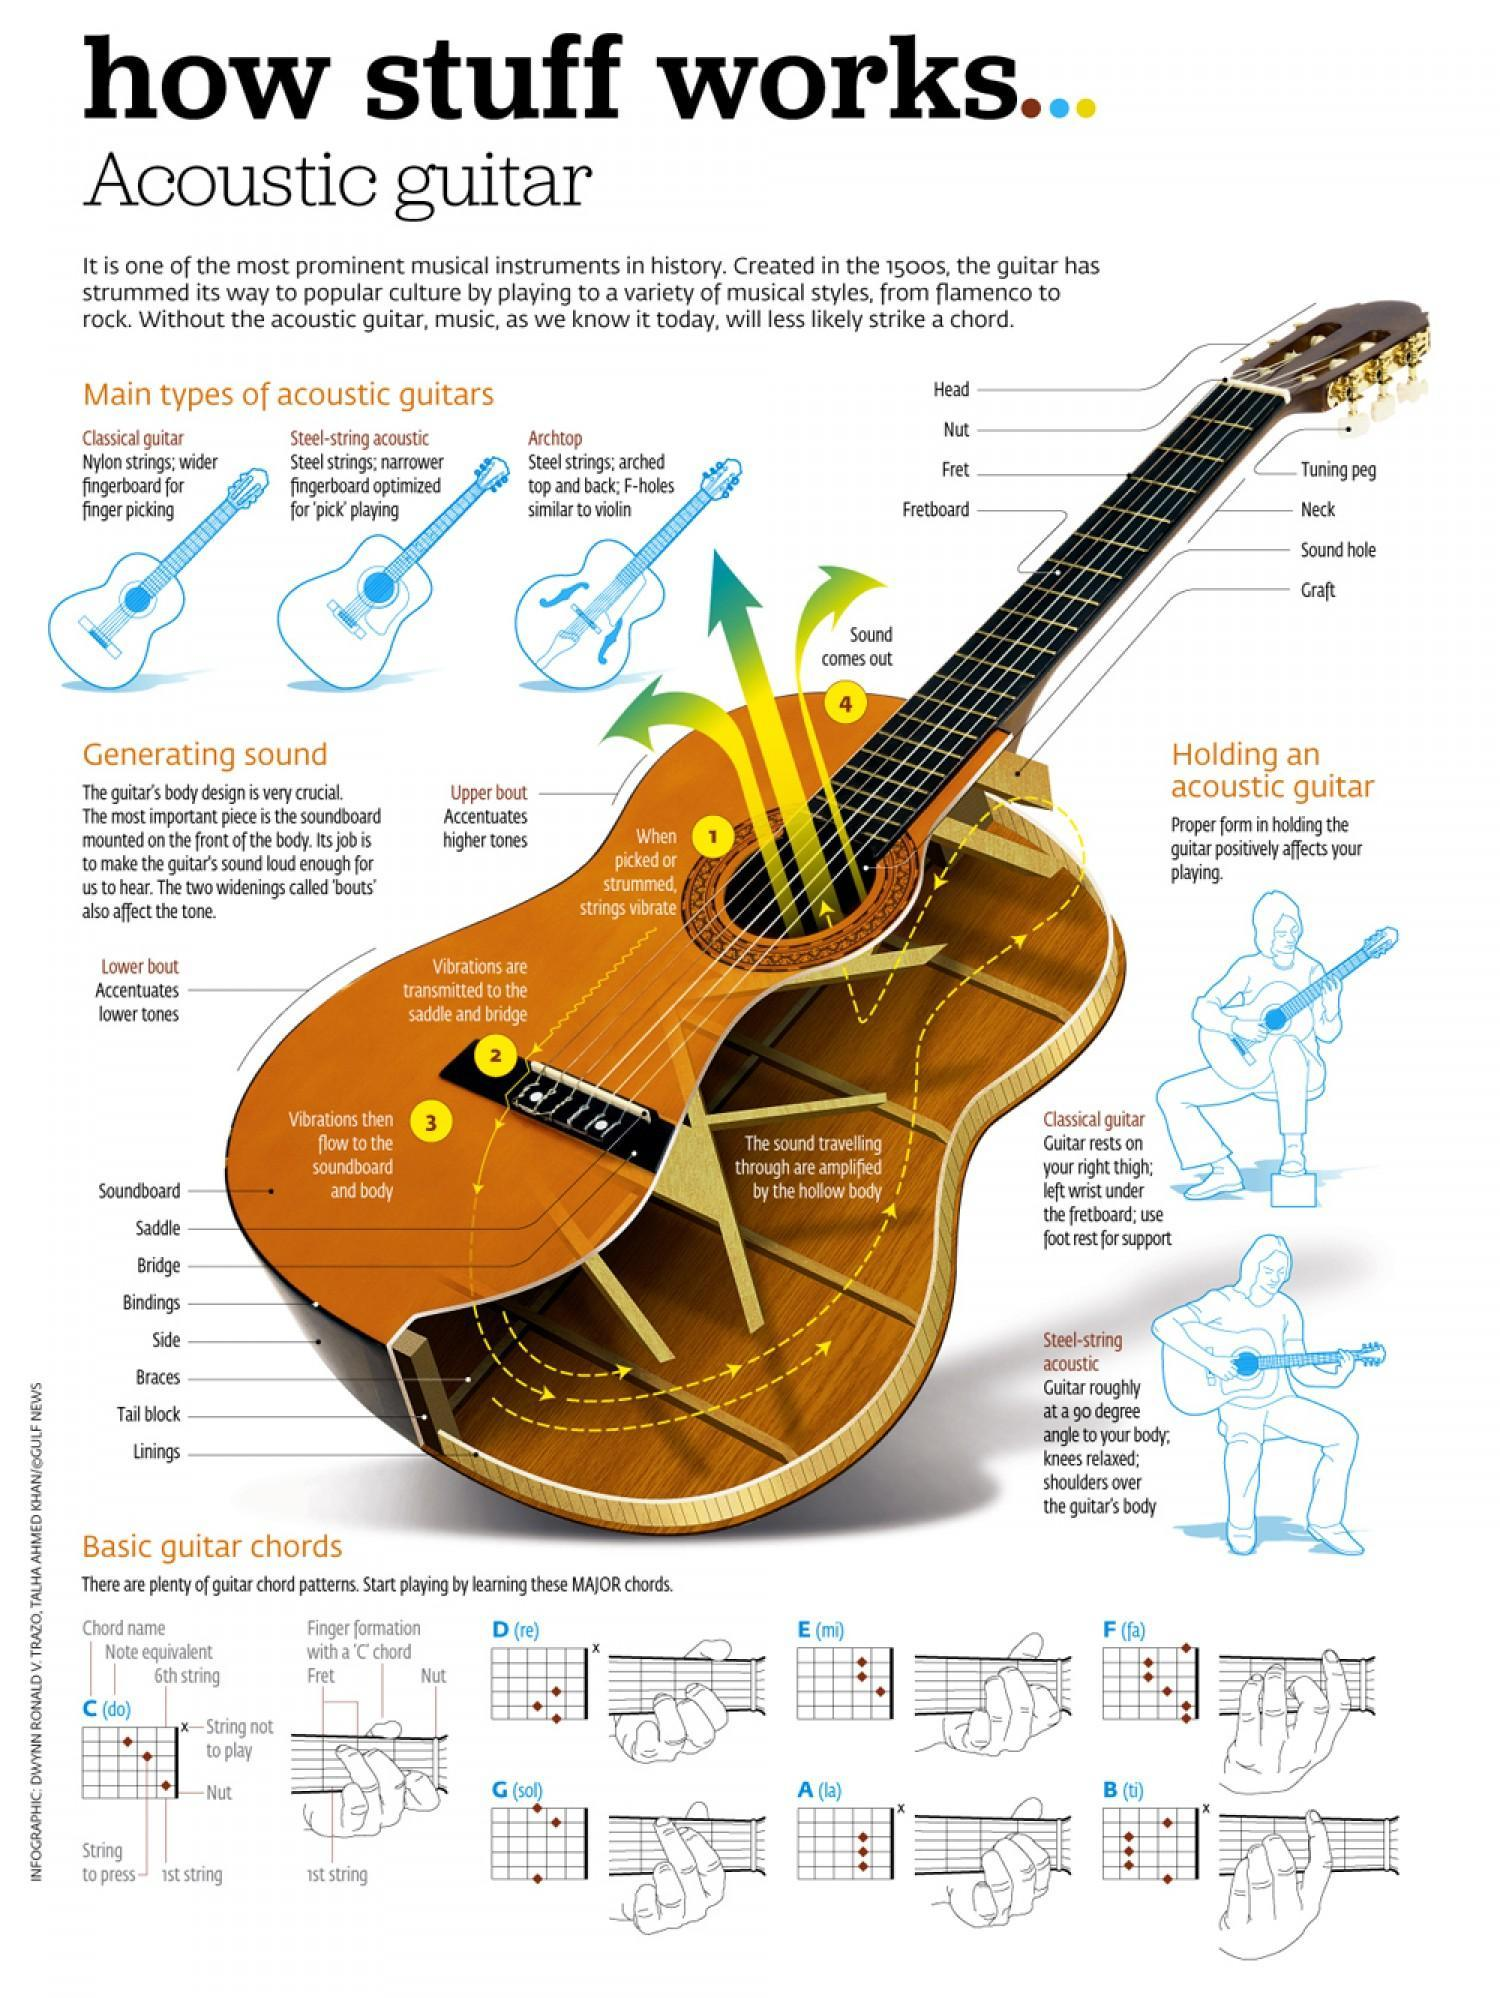Which type of Acoustic guitar has got F holes?
Answer the question with a short phrase. Archtop How the strings of guitar vibrate? When picked or strummed What is the function of Lower Bout? Accentuates lower tones What is the function of Upper Bout? Accentuates higher tones Which type of Acoustic guitar has got Nylon Strings? Classical Guitar How many different types of acoustic guitars are mentioned in the info graphic 3 Which type of Acoustic guitar is specially for pick playing? Steel-string acoustic 